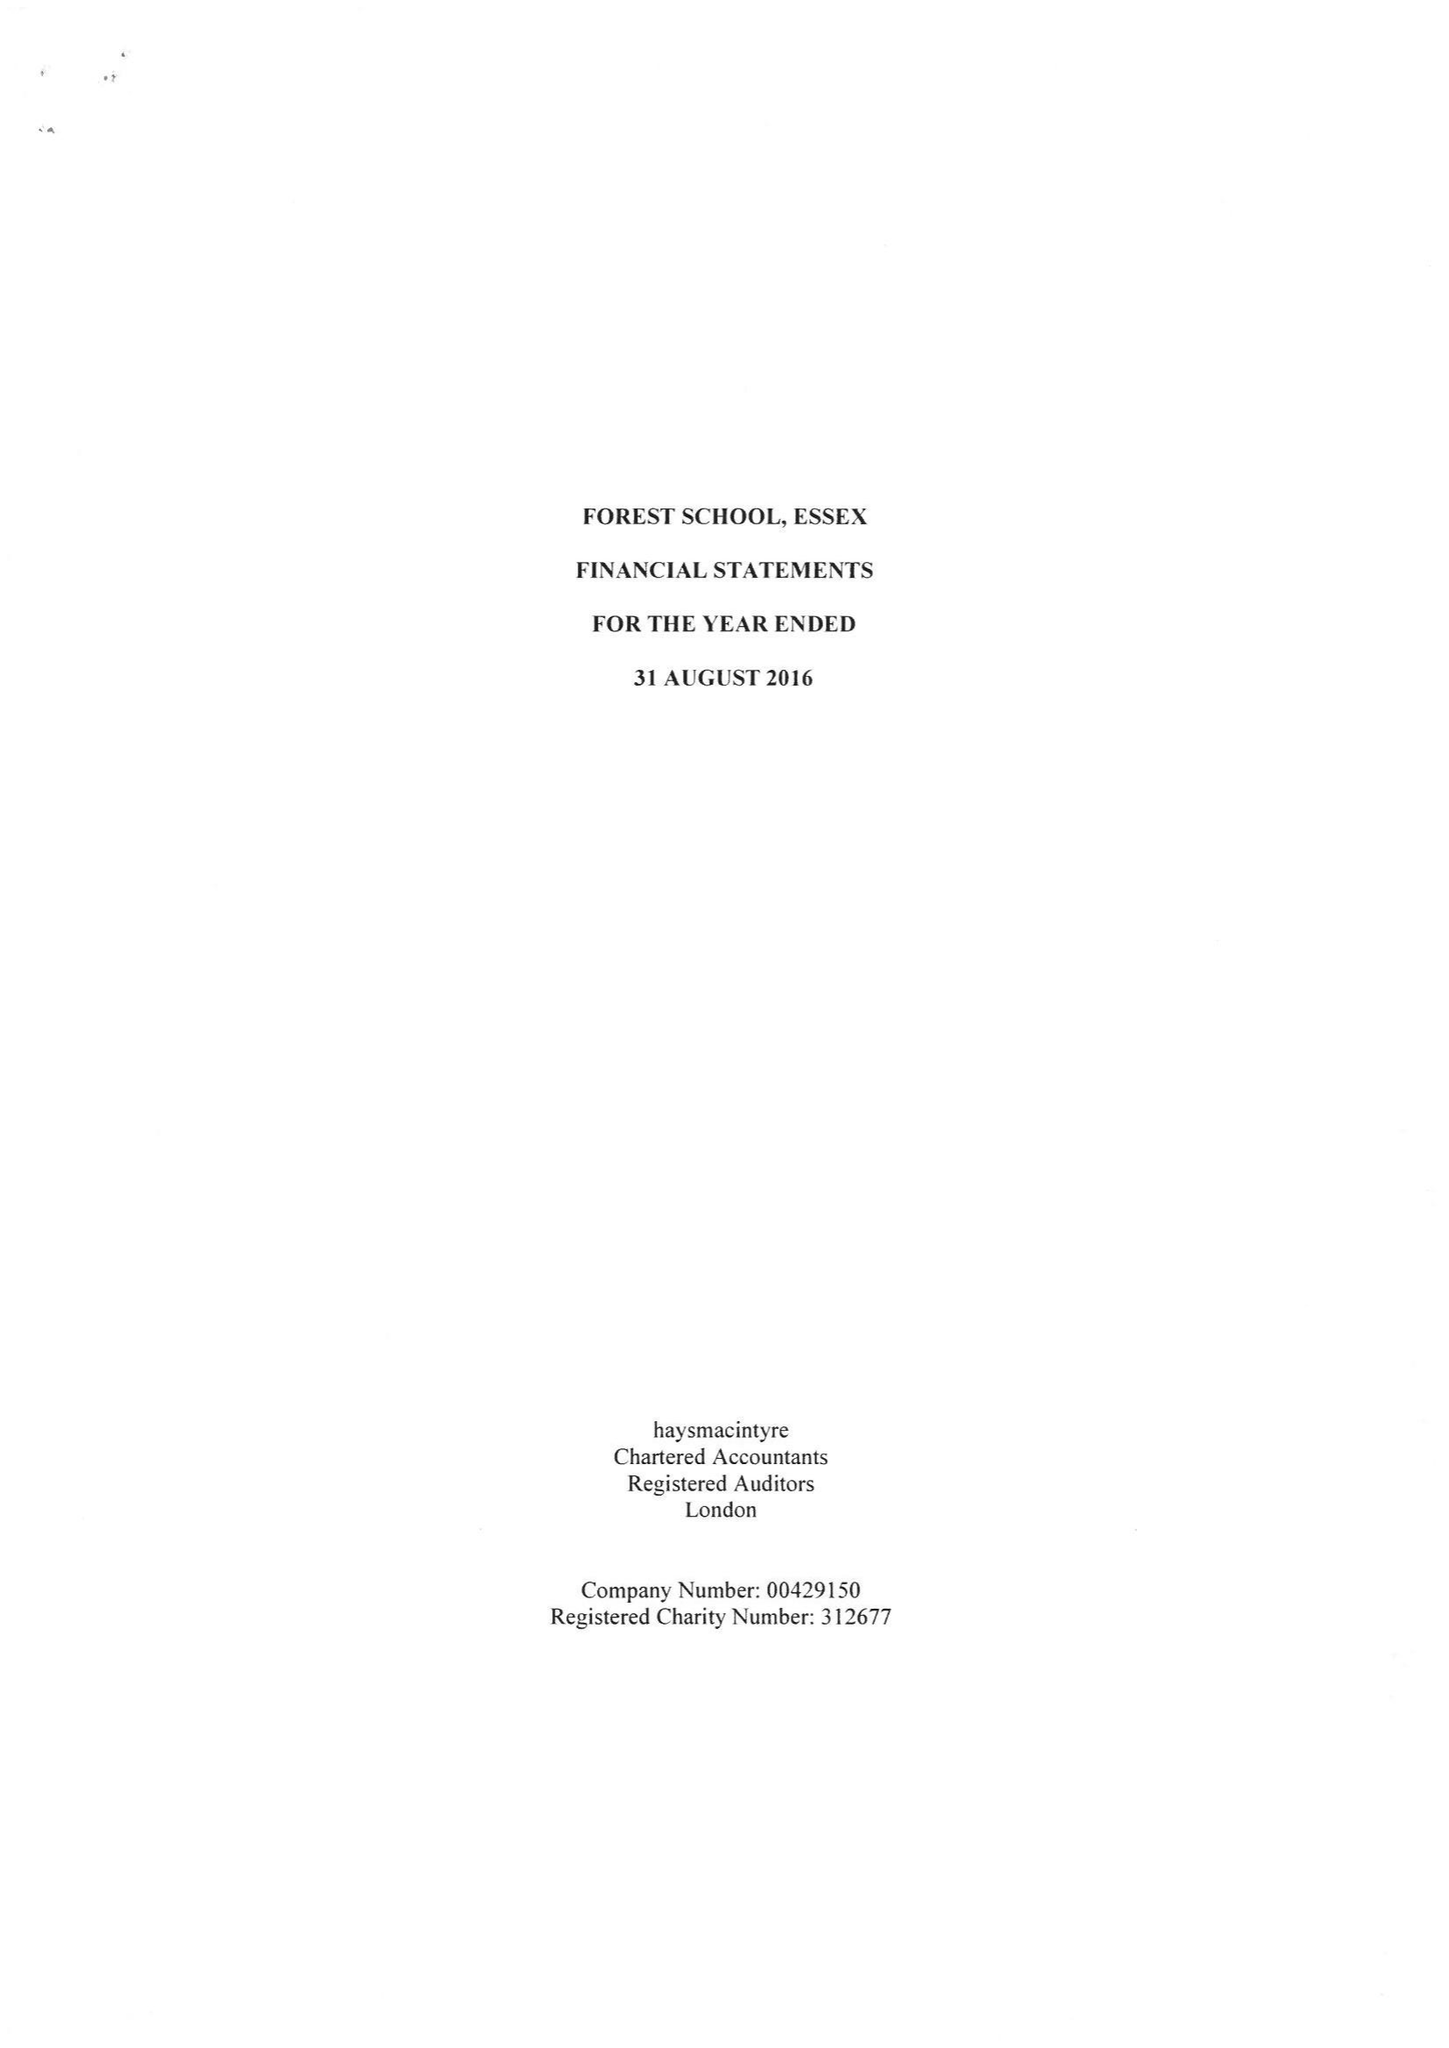What is the value for the charity_name?
Answer the question using a single word or phrase. Forest School, Essex 